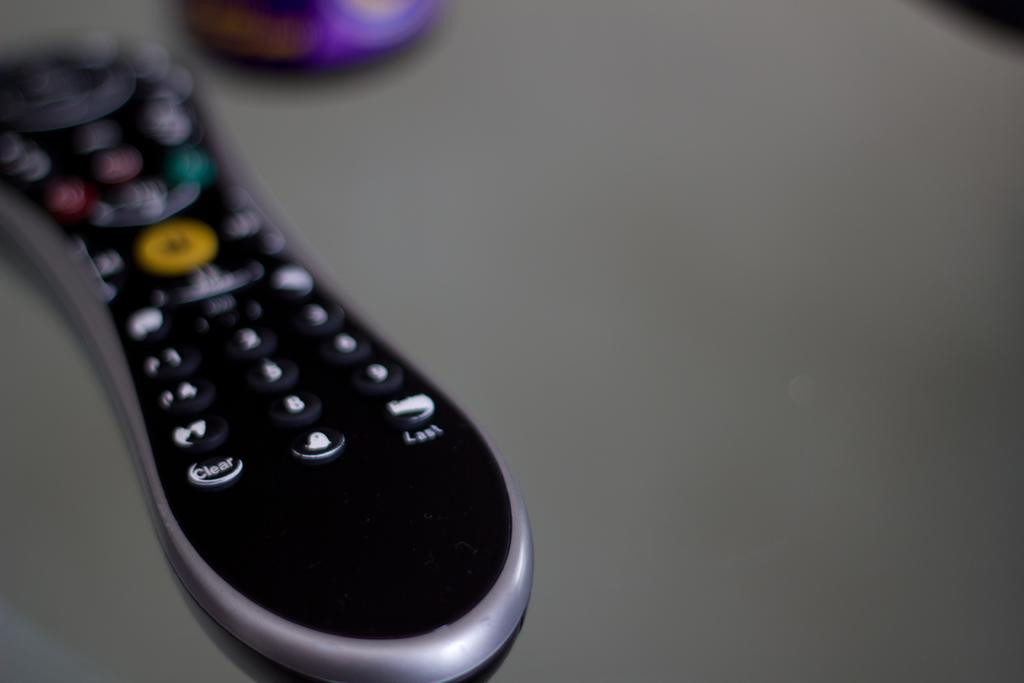<image>
Write a terse but informative summary of the picture. A remote controller with the bottom buttons that say clear, 0, and last 